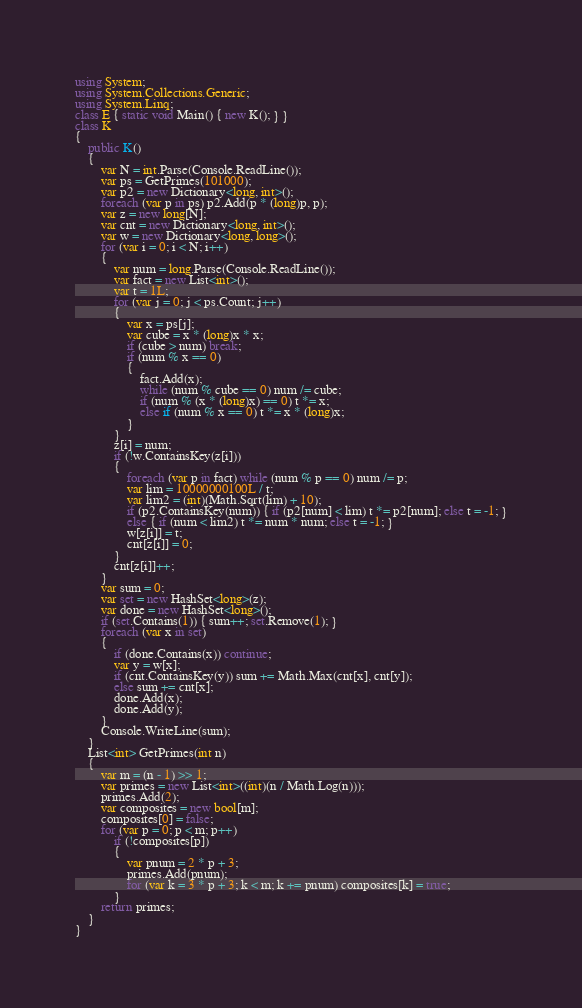<code> <loc_0><loc_0><loc_500><loc_500><_C#_>using System;
using System.Collections.Generic;
using System.Linq;
class E { static void Main() { new K(); } }
class K
{
	public K()
	{
		var N = int.Parse(Console.ReadLine());
		var ps = GetPrimes(101000);
		var p2 = new Dictionary<long, int>();
		foreach (var p in ps) p2.Add(p * (long)p, p);
		var z = new long[N];
		var cnt = new Dictionary<long, int>();
		var w = new Dictionary<long, long>();
		for (var i = 0; i < N; i++)
		{
			var num = long.Parse(Console.ReadLine());
			var fact = new List<int>();
			var t = 1L;
			for (var j = 0; j < ps.Count; j++)
			{
				var x = ps[j];
				var cube = x * (long)x * x;
				if (cube > num) break;
				if (num % x == 0)
				{
					fact.Add(x);
					while (num % cube == 0) num /= cube;
					if (num % (x * (long)x) == 0) t *= x;
					else if (num % x == 0) t *= x * (long)x;
				}
			}
			z[i] = num;
			if (!w.ContainsKey(z[i]))
			{
				foreach (var p in fact) while (num % p == 0) num /= p;
				var lim = 10000000100L / t;
				var lim2 = (int)(Math.Sqrt(lim) + 10);
				if (p2.ContainsKey(num)) { if (p2[num] < lim) t *= p2[num]; else t = -1; }
				else { if (num < lim2) t *= num * num; else t = -1; }
				w[z[i]] = t;
				cnt[z[i]] = 0;
			}
			cnt[z[i]]++;
		}
		var sum = 0;
		var set = new HashSet<long>(z);
		var done = new HashSet<long>();
		if (set.Contains(1)) { sum++; set.Remove(1); }
		foreach (var x in set)
		{
			if (done.Contains(x)) continue;
			var y = w[x];
			if (cnt.ContainsKey(y)) sum += Math.Max(cnt[x], cnt[y]);
			else sum += cnt[x];
			done.Add(x);
			done.Add(y);
		}
		Console.WriteLine(sum);
	}
	List<int> GetPrimes(int n)
	{
		var m = (n - 1) >> 1;
		var primes = new List<int>((int)(n / Math.Log(n)));
		primes.Add(2);
		var composites = new bool[m];
		composites[0] = false;
		for (var p = 0; p < m; p++)
			if (!composites[p])
			{
				var pnum = 2 * p + 3;
				primes.Add(pnum);
				for (var k = 3 * p + 3; k < m; k += pnum) composites[k] = true;
			}
		return primes;
	}
}</code> 